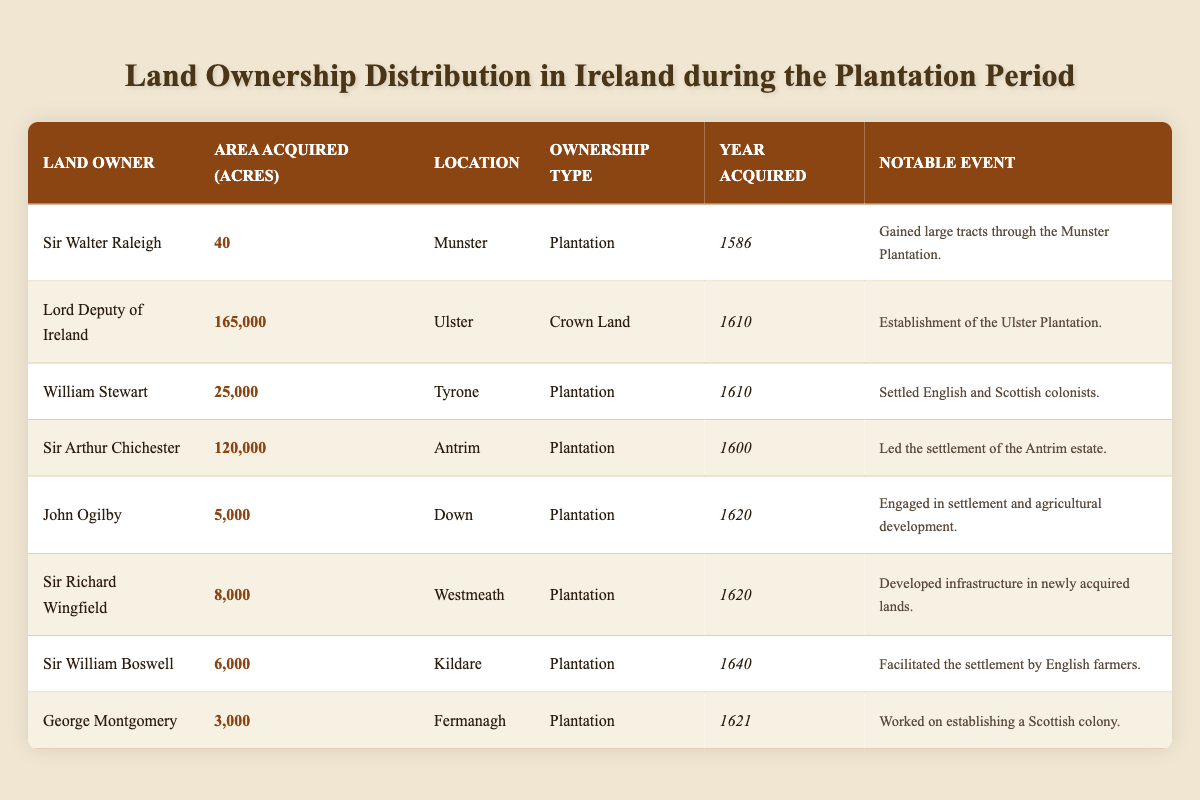What is the area acquired by Lord Deputy of Ireland? In the table, the row for "Lord Deputy of Ireland" shows that the area acquired is listed as 165,000 acres.
Answer: 165,000 acres Who acquired the smallest area of land and how much was it? By reviewing the table, "Sir Walter Raleigh" is shown to have acquired the smallest area, which is 40 acres.
Answer: 40 acres In which location did William Stewart acquire land? The table indicates that William Stewart acquired land in "Tyrone".
Answer: Tyrone How many acres did Sir Arthur Chichester acquire compared to John Ogilby? From the table, Sir Arthur Chichester acquired 120,000 acres, while John Ogilby acquired 5,000 acres; the difference is 120,000 - 5,000 = 115,000 acres.
Answer: 115,000 acres Which land owner acquired land in the year 1620? The table lists both John Ogilby and Sir Richard Wingfield as acquiring land in the year 1620.
Answer: John Ogilby and Sir Richard Wingfield What was the total area acquired by the land owners in Munster? Only Sir Walter Raleigh’s acquisition in Munster is listed as 40 acres, so the total area acquired in Munster is simply 40 acres.
Answer: 40 acres What is the total acreage acquired in Ulster and Tyrone? The table indicates that 165,000 acres were acquired in Ulster by Lord Deputy of Ireland and 25,000 acres in Tyrone by William Stewart. Thus, the total is 165,000 + 25,000 = 190,000 acres.
Answer: 190,000 acres How many landowners acquired land through the Plantation system? There are 6 land owners listed in the table under the ownership type "Plantation".
Answer: 6 Is it true that Sir Richard Wingfield acquired land in Westmeath? Yes, according to the table, Sir Richard Wingfield is noted as acquiring land in Westmeath.
Answer: Yes What was the average area acquired by land owners listed under the Plantation ownership? The total area acquired by the 6 plantation owners amounts to 40 + 25,000 + 120,000 + 5,000 + 8,000 + 6,000 = 164,040 acres. The average is 164,040 / 6 = approximately 27,340 acres.
Answer: Approximately 27,340 acres What significant event is associated with George Montgomery’s acquisition in Fermanagh? The notable event associated with George Montgomery is that he "Worked on establishing a Scottish colony" as per the table.
Answer: Established a Scottish colony 